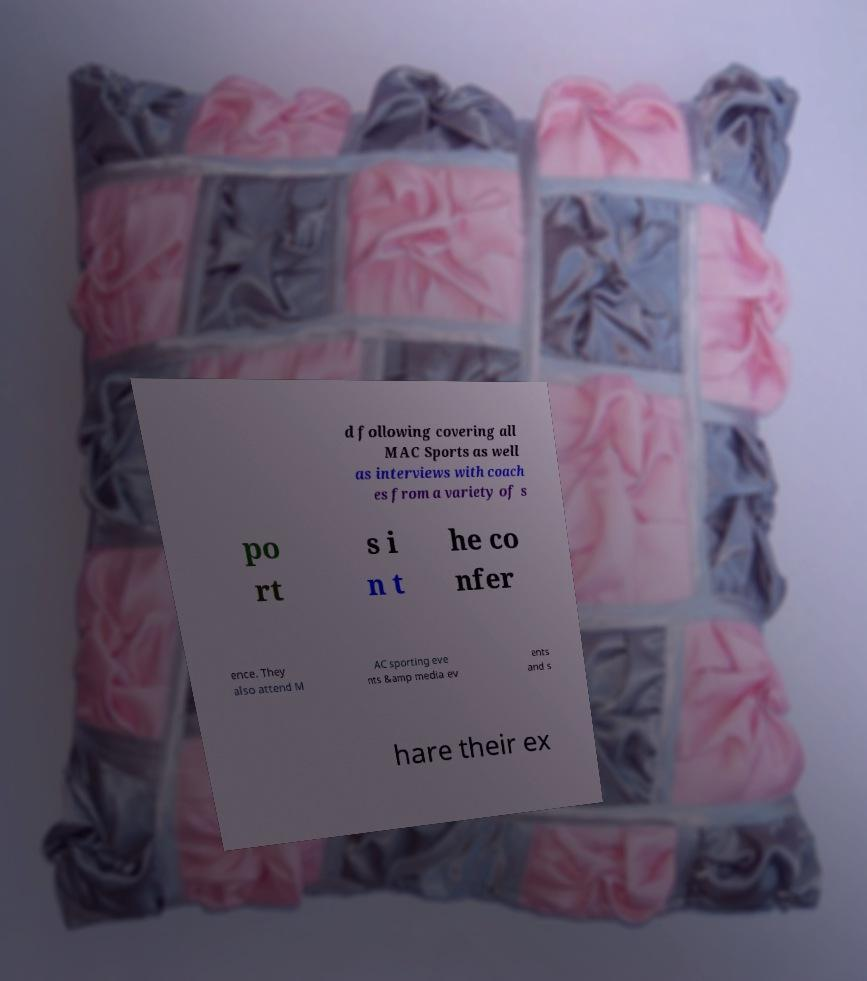Can you read and provide the text displayed in the image?This photo seems to have some interesting text. Can you extract and type it out for me? d following covering all MAC Sports as well as interviews with coach es from a variety of s po rt s i n t he co nfer ence. They also attend M AC sporting eve nts &amp media ev ents and s hare their ex 